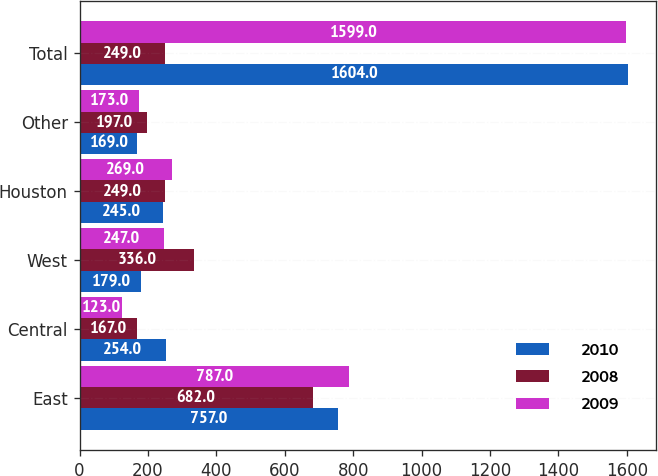<chart> <loc_0><loc_0><loc_500><loc_500><stacked_bar_chart><ecel><fcel>East<fcel>Central<fcel>West<fcel>Houston<fcel>Other<fcel>Total<nl><fcel>2010<fcel>757<fcel>254<fcel>179<fcel>245<fcel>169<fcel>1604<nl><fcel>2008<fcel>682<fcel>167<fcel>336<fcel>249<fcel>197<fcel>249<nl><fcel>2009<fcel>787<fcel>123<fcel>247<fcel>269<fcel>173<fcel>1599<nl></chart> 